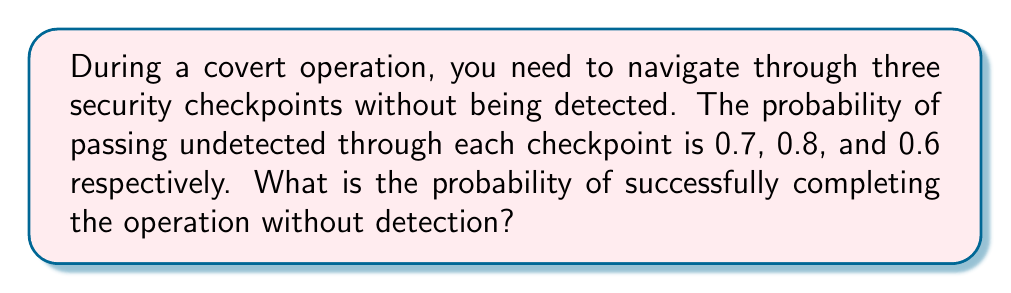Give your solution to this math problem. To solve this problem, we need to use the concept of independent events and the multiplication rule of probability.

Step 1: Identify the events
Let's define the events:
A: Passing undetected through checkpoint 1 (P(A) = 0.7)
B: Passing undetected through checkpoint 2 (P(B) = 0.8)
C: Passing undetected through checkpoint 3 (P(C) = 0.6)

Step 2: Determine the probability of success
To successfully complete the operation, you need to pass through all three checkpoints undetected. This means we need to calculate the probability of A AND B AND C occurring.

Step 3: Apply the multiplication rule
Since the events are independent (success at one checkpoint doesn't affect the probability of success at another), we can multiply their individual probabilities:

$$P(\text{Success}) = P(A) \times P(B) \times P(C)$$

Step 4: Calculate the final probability
$$P(\text{Success}) = 0.7 \times 0.8 \times 0.6 = 0.336$$

Therefore, the probability of successfully completing the operation without detection is 0.336 or 33.6%.
Answer: 0.336 